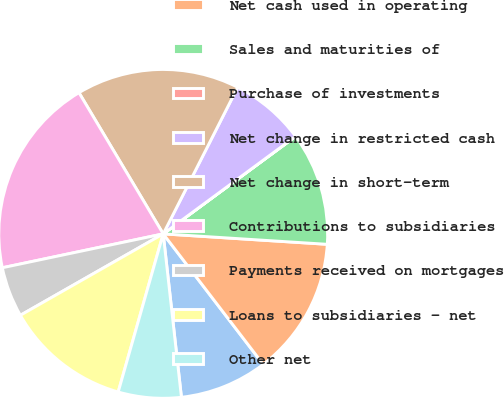Convert chart to OTSL. <chart><loc_0><loc_0><loc_500><loc_500><pie_chart><fcel>Years Ended December 31 (in<fcel>Net cash used in operating<fcel>Sales and maturities of<fcel>Purchase of investments<fcel>Net change in restricted cash<fcel>Net change in short-term<fcel>Contributions to subsidiaries<fcel>Payments received on mortgages<fcel>Loans to subsidiaries - net<fcel>Other net<nl><fcel>8.64%<fcel>13.58%<fcel>11.11%<fcel>0.01%<fcel>7.41%<fcel>16.04%<fcel>19.74%<fcel>4.94%<fcel>12.34%<fcel>6.18%<nl></chart> 